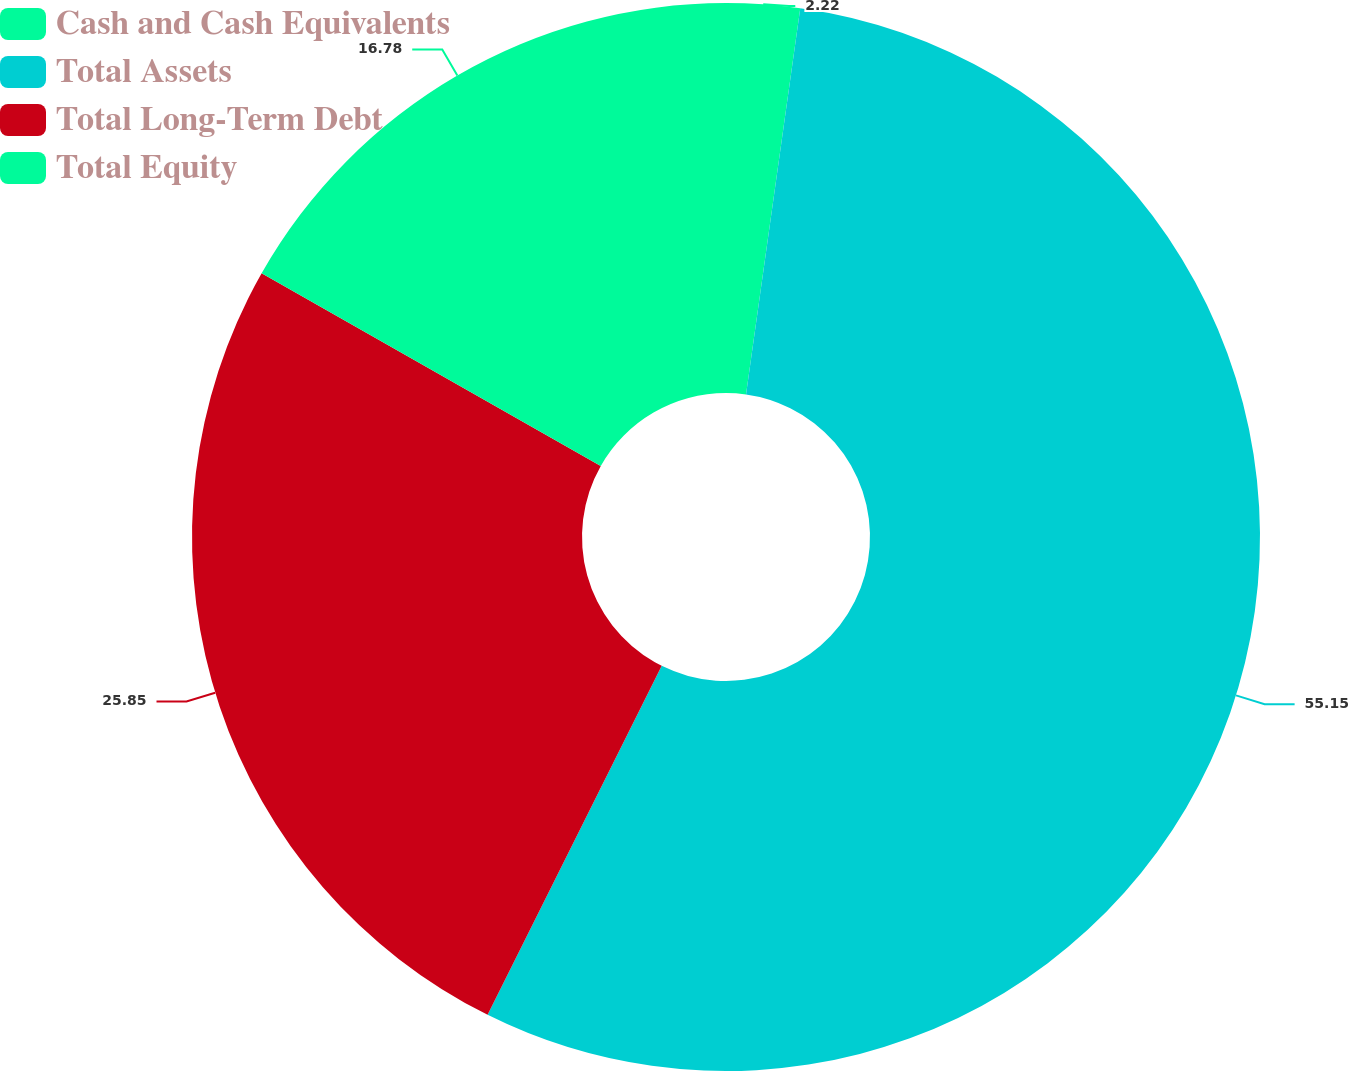Convert chart. <chart><loc_0><loc_0><loc_500><loc_500><pie_chart><fcel>Cash and Cash Equivalents<fcel>Total Assets<fcel>Total Long-Term Debt<fcel>Total Equity<nl><fcel>2.22%<fcel>55.14%<fcel>25.85%<fcel>16.78%<nl></chart> 